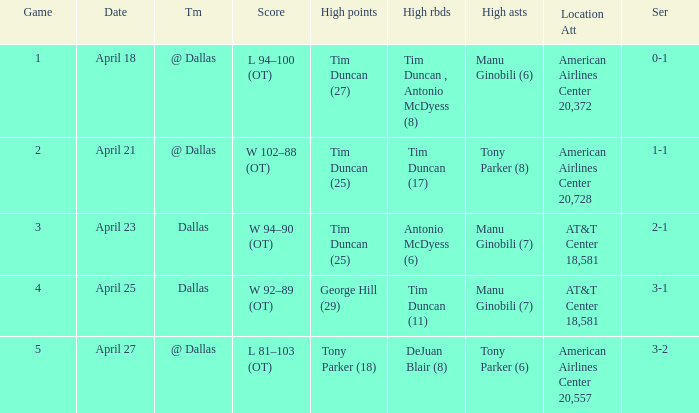When 5 is the game who has the highest amount of points? Tony Parker (18). 